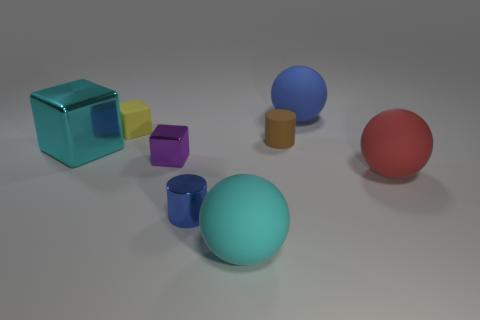Add 1 big cyan metallic objects. How many objects exist? 9 Subtract all blocks. How many objects are left? 5 Subtract 1 brown cylinders. How many objects are left? 7 Subtract all big cyan cubes. Subtract all tiny brown rubber objects. How many objects are left? 6 Add 2 large cyan matte objects. How many large cyan matte objects are left? 3 Add 6 tiny yellow metal objects. How many tiny yellow metal objects exist? 6 